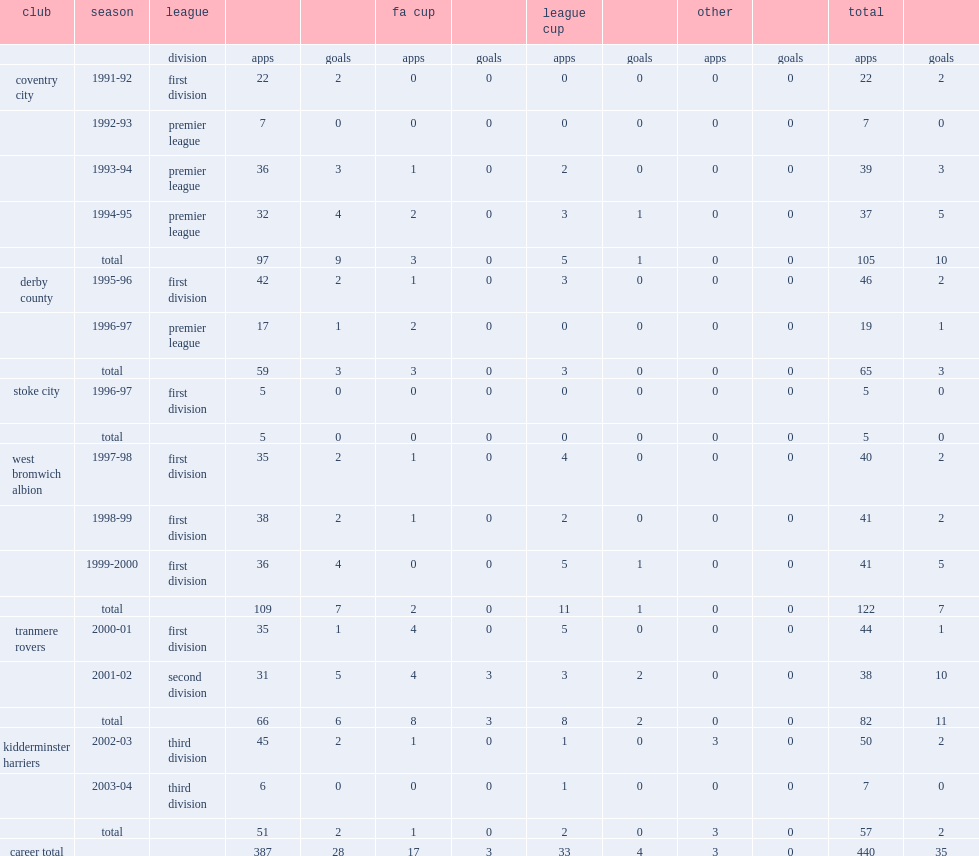How many games did sean flynn play for west bromwich albion totally? 122.0. Could you parse the entire table as a dict? {'header': ['club', 'season', 'league', '', '', 'fa cup', '', 'league cup', '', 'other', '', 'total', ''], 'rows': [['', '', 'division', 'apps', 'goals', 'apps', 'goals', 'apps', 'goals', 'apps', 'goals', 'apps', 'goals'], ['coventry city', '1991-92', 'first division', '22', '2', '0', '0', '0', '0', '0', '0', '22', '2'], ['', '1992-93', 'premier league', '7', '0', '0', '0', '0', '0', '0', '0', '7', '0'], ['', '1993-94', 'premier league', '36', '3', '1', '0', '2', '0', '0', '0', '39', '3'], ['', '1994-95', 'premier league', '32', '4', '2', '0', '3', '1', '0', '0', '37', '5'], ['', 'total', '', '97', '9', '3', '0', '5', '1', '0', '0', '105', '10'], ['derby county', '1995-96', 'first division', '42', '2', '1', '0', '3', '0', '0', '0', '46', '2'], ['', '1996-97', 'premier league', '17', '1', '2', '0', '0', '0', '0', '0', '19', '1'], ['', 'total', '', '59', '3', '3', '0', '3', '0', '0', '0', '65', '3'], ['stoke city', '1996-97', 'first division', '5', '0', '0', '0', '0', '0', '0', '0', '5', '0'], ['', 'total', '', '5', '0', '0', '0', '0', '0', '0', '0', '5', '0'], ['west bromwich albion', '1997-98', 'first division', '35', '2', '1', '0', '4', '0', '0', '0', '40', '2'], ['', '1998-99', 'first division', '38', '2', '1', '0', '2', '0', '0', '0', '41', '2'], ['', '1999-2000', 'first division', '36', '4', '0', '0', '5', '1', '0', '0', '41', '5'], ['', 'total', '', '109', '7', '2', '0', '11', '1', '0', '0', '122', '7'], ['tranmere rovers', '2000-01', 'first division', '35', '1', '4', '0', '5', '0', '0', '0', '44', '1'], ['', '2001-02', 'second division', '31', '5', '4', '3', '3', '2', '0', '0', '38', '10'], ['', 'total', '', '66', '6', '8', '3', '8', '2', '0', '0', '82', '11'], ['kidderminster harriers', '2002-03', 'third division', '45', '2', '1', '0', '1', '0', '3', '0', '50', '2'], ['', '2003-04', 'third division', '6', '0', '0', '0', '1', '0', '0', '0', '7', '0'], ['', 'total', '', '51', '2', '1', '0', '2', '0', '3', '0', '57', '2'], ['career total', '', '', '387', '28', '17', '3', '33', '4', '3', '0', '440', '35']]} 